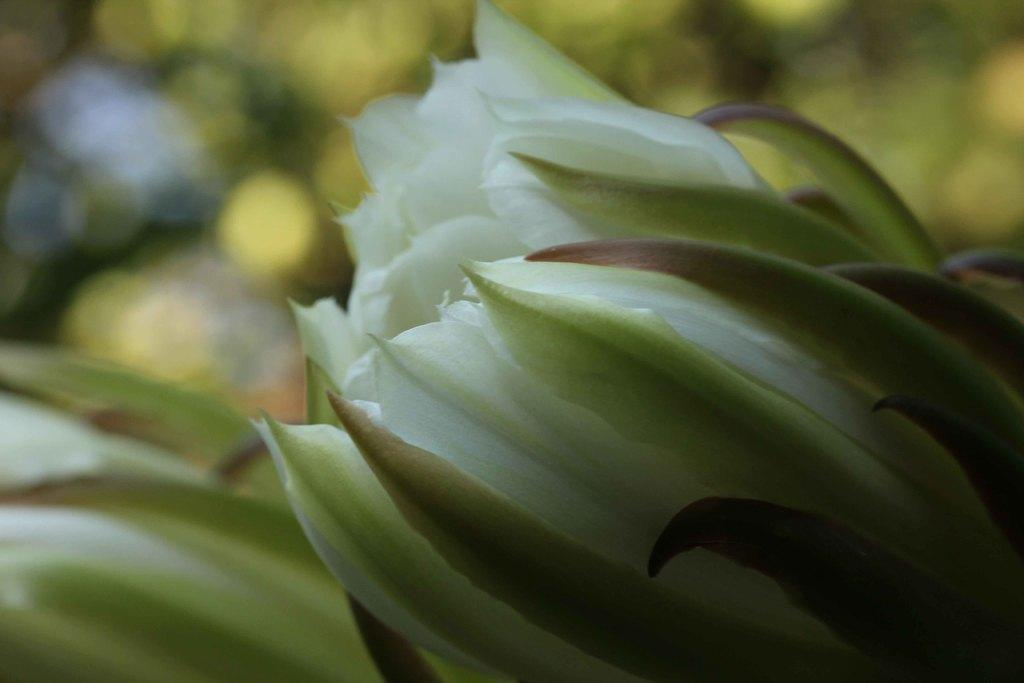What type of flowers are in the front of the image? There are white color flowers in the front of the image. Can you describe the background of the image? The background of the image is blurred. What type of snake can be seen slithering through the flowers in the image? There is no snake present in the image; it only features white color flowers. 